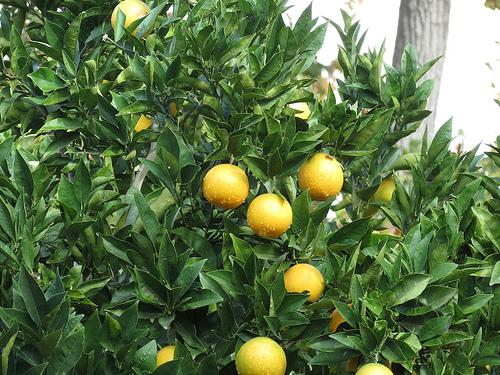Question: what type of fruit is in the picture?
Choices:
A. Limes.
B. Lemons.
C. Apples.
D. Oranges.
Answer with the letter. Answer: D Question: who took this picture?
Choices:
A. A painter.
B. A farmer.
C. A artisan.
D. A plumber.
Answer with the letter. Answer: B Question: what season is it in the picture?
Choices:
A. Winter.
B. Autumn.
C. Spring.
D. Summer.
Answer with the letter. Answer: D Question: how long before the oranges are ready to eat?
Choices:
A. A month.
B. A week.
C. A couple years.
D. Ready now.
Answer with the letter. Answer: D 